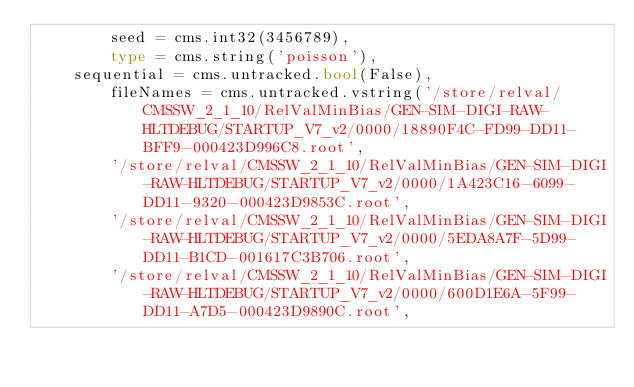<code> <loc_0><loc_0><loc_500><loc_500><_Python_>        seed = cms.int32(3456789),
        type = cms.string('poisson'),
	sequential = cms.untracked.bool(False),
        fileNames = cms.untracked.vstring('/store/relval/CMSSW_2_1_10/RelValMinBias/GEN-SIM-DIGI-RAW-HLTDEBUG/STARTUP_V7_v2/0000/18890F4C-FD99-DD11-BFF9-000423D996C8.root',
        '/store/relval/CMSSW_2_1_10/RelValMinBias/GEN-SIM-DIGI-RAW-HLTDEBUG/STARTUP_V7_v2/0000/1A423C16-6099-DD11-9320-000423D9853C.root',
        '/store/relval/CMSSW_2_1_10/RelValMinBias/GEN-SIM-DIGI-RAW-HLTDEBUG/STARTUP_V7_v2/0000/5EDA8A7F-5D99-DD11-B1CD-001617C3B706.root',
        '/store/relval/CMSSW_2_1_10/RelValMinBias/GEN-SIM-DIGI-RAW-HLTDEBUG/STARTUP_V7_v2/0000/600D1E6A-5F99-DD11-A7D5-000423D9890C.root',</code> 